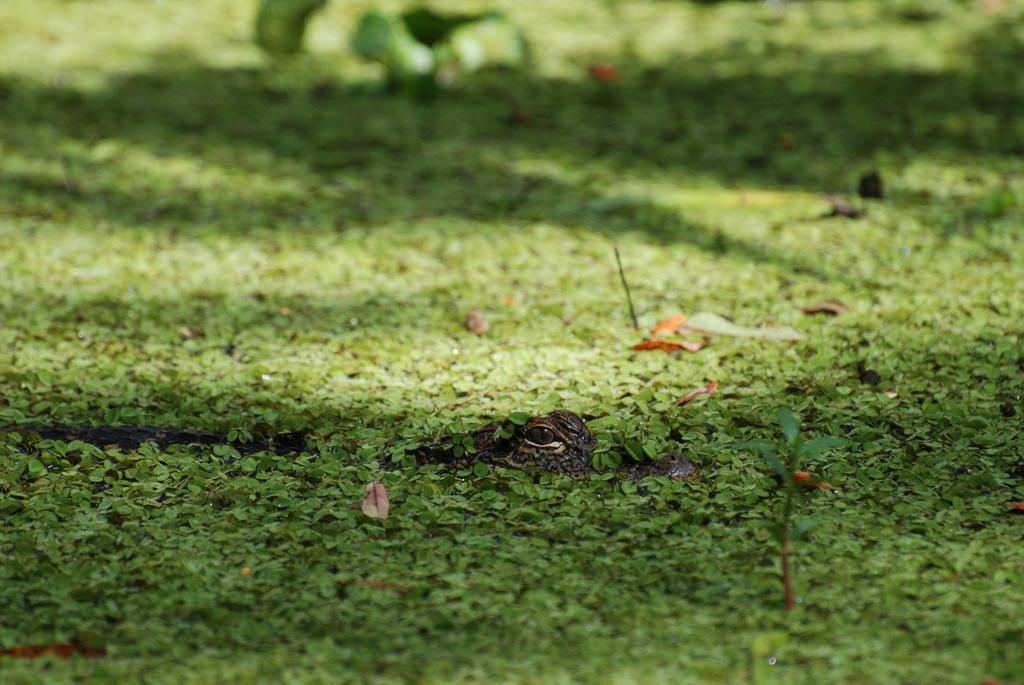What animal is present in the image? There is a crocodile in the image. Where is the crocodile located? The crocodile is on the surface of leaves. What type of cake is your dad holding in the image? There is no reference to a dad or a cake in the image; it features a crocodile on the surface of leaves. 